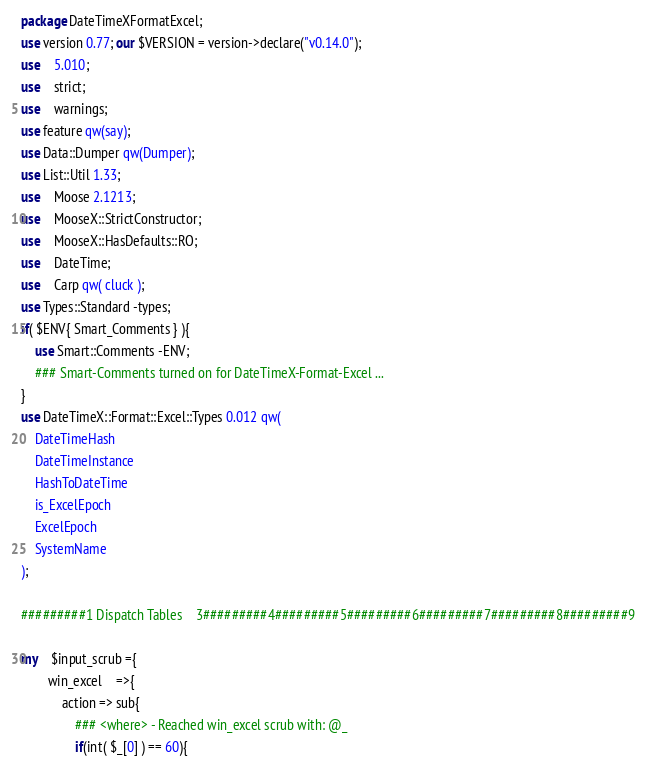<code> <loc_0><loc_0><loc_500><loc_500><_Perl_>package DateTimeXFormatExcel;
use version 0.77; our $VERSION = version->declare("v0.14.0");
use	5.010;
use	strict;
use	warnings;
use feature qw(say);
use Data::Dumper qw(Dumper);
use List::Util 1.33;
use	Moose 2.1213;
use	MooseX::StrictConstructor;
use	MooseX::HasDefaults::RO;
use	DateTime;
use	Carp qw( cluck );
use Types::Standard -types;
if( $ENV{ Smart_Comments } ){
	use Smart::Comments -ENV;
	### Smart-Comments turned on for DateTimeX-Format-Excel ...
}
use DateTimeX::Format::Excel::Types 0.012 qw(
	DateTimeHash
	DateTimeInstance
	HashToDateTime
	is_ExcelEpoch
	ExcelEpoch
	SystemName
);

#########1 Dispatch Tables    3#########4#########5#########6#########7#########8#########9

my	$input_scrub ={
		win_excel	=>{
			action => sub{
				### <where> - Reached win_excel scrub with: @_
				if(int( $_[0] ) == 60){</code> 